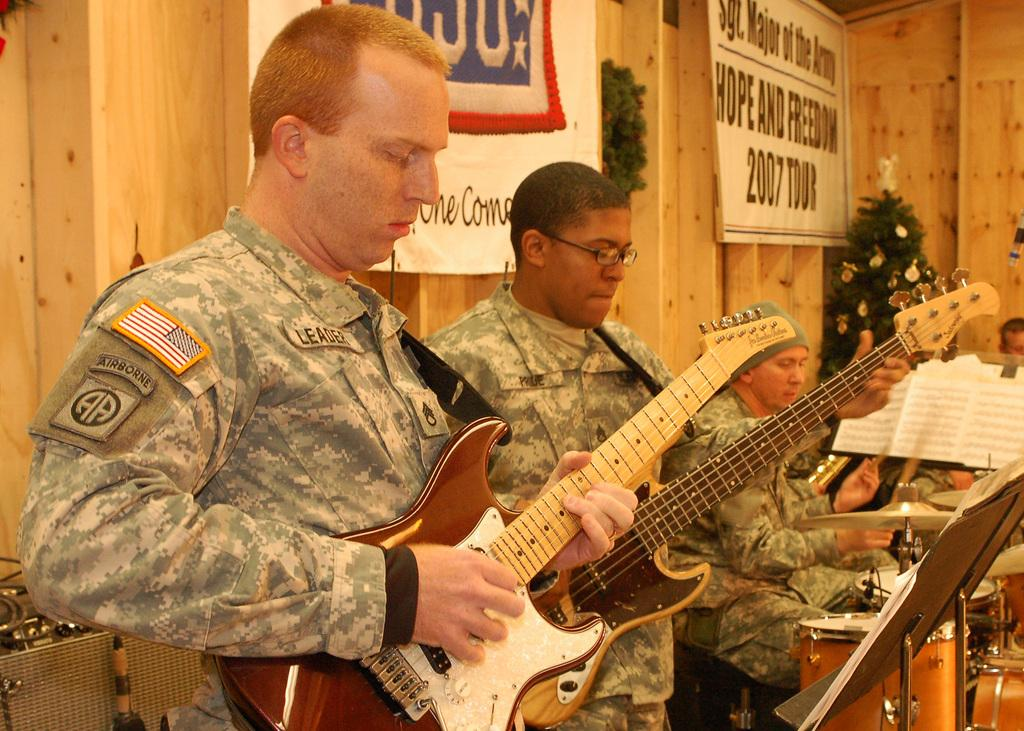What is the main subject of the image? The main subject of the image is a man. What is the man holding in the image? The man is holding a guitar. Are there any other people in the image? Yes, there are other people in the image. What are these people doing? These people are playing musical instruments. What type of boundary can be seen in the image? There is no boundary present in the image. What meal are the people in the image about to have? There is no meal depicted in the image; the people are playing musical instruments. 